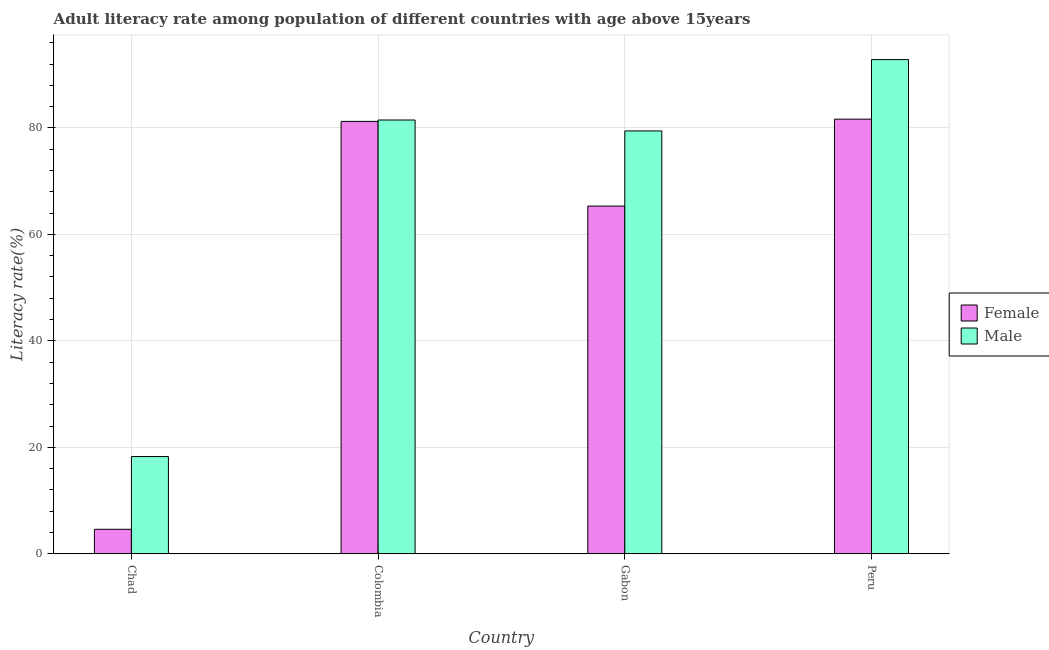How many groups of bars are there?
Provide a succinct answer. 4. Are the number of bars on each tick of the X-axis equal?
Provide a succinct answer. Yes. How many bars are there on the 3rd tick from the right?
Give a very brief answer. 2. What is the label of the 4th group of bars from the left?
Your answer should be very brief. Peru. In how many cases, is the number of bars for a given country not equal to the number of legend labels?
Your response must be concise. 0. What is the male adult literacy rate in Gabon?
Your answer should be compact. 79.44. Across all countries, what is the maximum female adult literacy rate?
Make the answer very short. 81.66. Across all countries, what is the minimum male adult literacy rate?
Your response must be concise. 18.26. In which country was the female adult literacy rate minimum?
Your answer should be very brief. Chad. What is the total female adult literacy rate in the graph?
Keep it short and to the point. 232.81. What is the difference between the female adult literacy rate in Chad and that in Colombia?
Keep it short and to the point. -76.64. What is the difference between the female adult literacy rate in Chad and the male adult literacy rate in Colombia?
Your response must be concise. -76.91. What is the average female adult literacy rate per country?
Make the answer very short. 58.2. What is the difference between the female adult literacy rate and male adult literacy rate in Colombia?
Make the answer very short. -0.26. What is the ratio of the female adult literacy rate in Chad to that in Peru?
Make the answer very short. 0.06. Is the male adult literacy rate in Chad less than that in Gabon?
Offer a very short reply. Yes. Is the difference between the female adult literacy rate in Colombia and Peru greater than the difference between the male adult literacy rate in Colombia and Peru?
Make the answer very short. Yes. What is the difference between the highest and the second highest male adult literacy rate?
Ensure brevity in your answer.  11.35. What is the difference between the highest and the lowest female adult literacy rate?
Make the answer very short. 77.07. What does the 1st bar from the right in Colombia represents?
Your answer should be compact. Male. How many countries are there in the graph?
Make the answer very short. 4. Does the graph contain grids?
Your response must be concise. Yes. Where does the legend appear in the graph?
Give a very brief answer. Center right. What is the title of the graph?
Keep it short and to the point. Adult literacy rate among population of different countries with age above 15years. Does "Private credit bureau" appear as one of the legend labels in the graph?
Offer a terse response. No. What is the label or title of the X-axis?
Offer a terse response. Country. What is the label or title of the Y-axis?
Offer a terse response. Literacy rate(%). What is the Literacy rate(%) in Female in Chad?
Offer a terse response. 4.59. What is the Literacy rate(%) of Male in Chad?
Ensure brevity in your answer.  18.26. What is the Literacy rate(%) in Female in Colombia?
Your answer should be compact. 81.24. What is the Literacy rate(%) in Male in Colombia?
Keep it short and to the point. 81.5. What is the Literacy rate(%) of Female in Gabon?
Your answer should be very brief. 65.33. What is the Literacy rate(%) of Male in Gabon?
Provide a succinct answer. 79.44. What is the Literacy rate(%) in Female in Peru?
Provide a short and direct response. 81.66. What is the Literacy rate(%) of Male in Peru?
Provide a succinct answer. 92.85. Across all countries, what is the maximum Literacy rate(%) in Female?
Give a very brief answer. 81.66. Across all countries, what is the maximum Literacy rate(%) of Male?
Give a very brief answer. 92.85. Across all countries, what is the minimum Literacy rate(%) of Female?
Offer a terse response. 4.59. Across all countries, what is the minimum Literacy rate(%) of Male?
Your answer should be compact. 18.26. What is the total Literacy rate(%) in Female in the graph?
Provide a short and direct response. 232.81. What is the total Literacy rate(%) of Male in the graph?
Make the answer very short. 272.05. What is the difference between the Literacy rate(%) in Female in Chad and that in Colombia?
Provide a succinct answer. -76.64. What is the difference between the Literacy rate(%) of Male in Chad and that in Colombia?
Provide a short and direct response. -63.24. What is the difference between the Literacy rate(%) of Female in Chad and that in Gabon?
Your answer should be very brief. -60.73. What is the difference between the Literacy rate(%) in Male in Chad and that in Gabon?
Offer a very short reply. -61.18. What is the difference between the Literacy rate(%) in Female in Chad and that in Peru?
Your answer should be compact. -77.07. What is the difference between the Literacy rate(%) of Male in Chad and that in Peru?
Provide a short and direct response. -74.59. What is the difference between the Literacy rate(%) of Female in Colombia and that in Gabon?
Your response must be concise. 15.91. What is the difference between the Literacy rate(%) of Male in Colombia and that in Gabon?
Provide a succinct answer. 2.05. What is the difference between the Literacy rate(%) in Female in Colombia and that in Peru?
Offer a very short reply. -0.42. What is the difference between the Literacy rate(%) in Male in Colombia and that in Peru?
Your answer should be very brief. -11.35. What is the difference between the Literacy rate(%) of Female in Gabon and that in Peru?
Provide a succinct answer. -16.33. What is the difference between the Literacy rate(%) in Male in Gabon and that in Peru?
Your answer should be very brief. -13.41. What is the difference between the Literacy rate(%) of Female in Chad and the Literacy rate(%) of Male in Colombia?
Provide a short and direct response. -76.91. What is the difference between the Literacy rate(%) in Female in Chad and the Literacy rate(%) in Male in Gabon?
Give a very brief answer. -74.85. What is the difference between the Literacy rate(%) in Female in Chad and the Literacy rate(%) in Male in Peru?
Provide a short and direct response. -88.26. What is the difference between the Literacy rate(%) in Female in Colombia and the Literacy rate(%) in Male in Gabon?
Keep it short and to the point. 1.79. What is the difference between the Literacy rate(%) in Female in Colombia and the Literacy rate(%) in Male in Peru?
Offer a very short reply. -11.62. What is the difference between the Literacy rate(%) in Female in Gabon and the Literacy rate(%) in Male in Peru?
Ensure brevity in your answer.  -27.52. What is the average Literacy rate(%) of Female per country?
Make the answer very short. 58.2. What is the average Literacy rate(%) in Male per country?
Your answer should be very brief. 68.01. What is the difference between the Literacy rate(%) of Female and Literacy rate(%) of Male in Chad?
Ensure brevity in your answer.  -13.67. What is the difference between the Literacy rate(%) of Female and Literacy rate(%) of Male in Colombia?
Your answer should be very brief. -0.26. What is the difference between the Literacy rate(%) in Female and Literacy rate(%) in Male in Gabon?
Your response must be concise. -14.12. What is the difference between the Literacy rate(%) of Female and Literacy rate(%) of Male in Peru?
Your response must be concise. -11.19. What is the ratio of the Literacy rate(%) in Female in Chad to that in Colombia?
Make the answer very short. 0.06. What is the ratio of the Literacy rate(%) of Male in Chad to that in Colombia?
Offer a very short reply. 0.22. What is the ratio of the Literacy rate(%) of Female in Chad to that in Gabon?
Provide a short and direct response. 0.07. What is the ratio of the Literacy rate(%) in Male in Chad to that in Gabon?
Your answer should be compact. 0.23. What is the ratio of the Literacy rate(%) of Female in Chad to that in Peru?
Make the answer very short. 0.06. What is the ratio of the Literacy rate(%) of Male in Chad to that in Peru?
Provide a succinct answer. 0.2. What is the ratio of the Literacy rate(%) in Female in Colombia to that in Gabon?
Give a very brief answer. 1.24. What is the ratio of the Literacy rate(%) in Male in Colombia to that in Gabon?
Ensure brevity in your answer.  1.03. What is the ratio of the Literacy rate(%) of Female in Colombia to that in Peru?
Provide a short and direct response. 0.99. What is the ratio of the Literacy rate(%) of Male in Colombia to that in Peru?
Provide a short and direct response. 0.88. What is the ratio of the Literacy rate(%) of Male in Gabon to that in Peru?
Ensure brevity in your answer.  0.86. What is the difference between the highest and the second highest Literacy rate(%) of Female?
Your answer should be compact. 0.42. What is the difference between the highest and the second highest Literacy rate(%) in Male?
Keep it short and to the point. 11.35. What is the difference between the highest and the lowest Literacy rate(%) in Female?
Give a very brief answer. 77.07. What is the difference between the highest and the lowest Literacy rate(%) in Male?
Give a very brief answer. 74.59. 